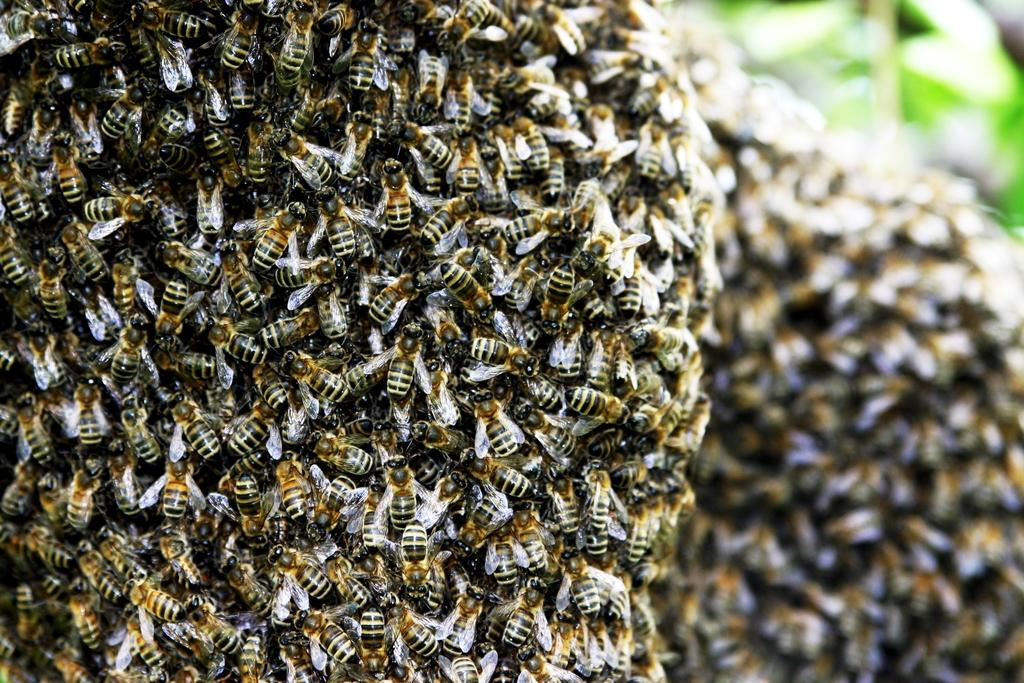What type of insects are present in the image? There are honey bees in the image. What type of mine can be seen in the image? There is no mine present in the image; it features honey bees. How many fingers can be seen in the image? There is no reference to fingers in the image, as it features honey bees. 